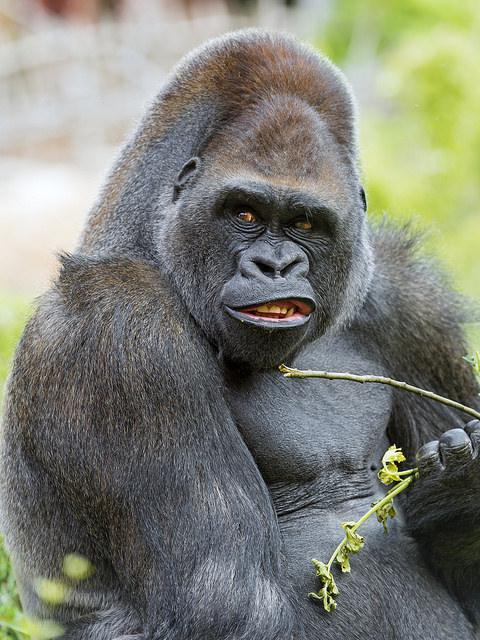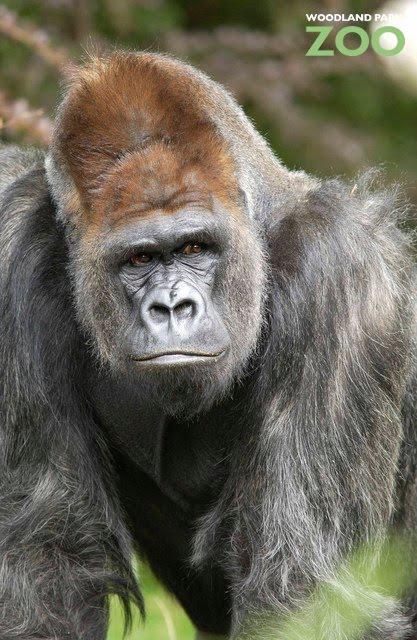The first image is the image on the left, the second image is the image on the right. Given the left and right images, does the statement "No image contains more than one gorilla, and each gorilla is gazing in a way that its eyes are visible." hold true? Answer yes or no. Yes. The first image is the image on the left, the second image is the image on the right. For the images displayed, is the sentence "The ape on the right is eating something." factually correct? Answer yes or no. No. 